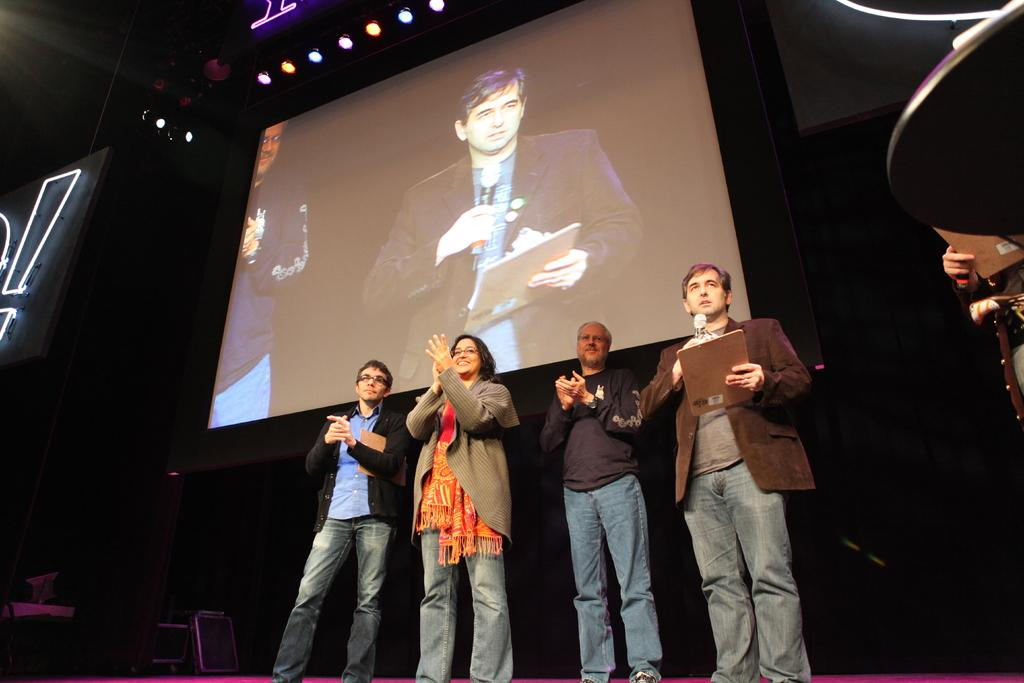How many people are on the dais in the image? There are four persons standing on the dais in the image. What is located in the background behind the dais? There is a projector screen in the background. What can be seen on the right side of the image? There is a table on the right side. What is visible at the top of the image? There are lights at the top of the image. What type of plantation can be seen in the image? There is no plantation present in the image. How does the secretary assist the persons on the dais in the image? There is no secretary present in the image. 